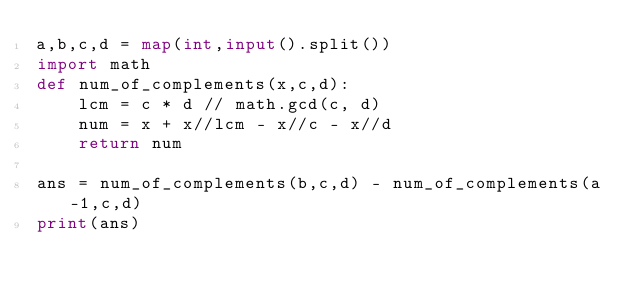<code> <loc_0><loc_0><loc_500><loc_500><_Python_>a,b,c,d = map(int,input().split())
import math
def num_of_complements(x,c,d):
    lcm = c * d // math.gcd(c, d)
    num = x + x//lcm - x//c - x//d
    return num

ans = num_of_complements(b,c,d) - num_of_complements(a-1,c,d)
print(ans)

</code> 